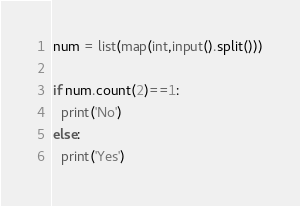Convert code to text. <code><loc_0><loc_0><loc_500><loc_500><_Python_>num = list(map(int,input().split()))

if num.count(2)==1:
  print('No')
else:
  print('Yes')</code> 